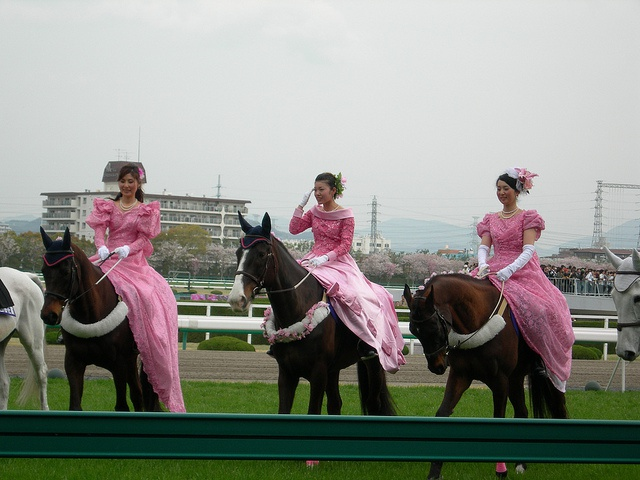Describe the objects in this image and their specific colors. I can see horse in lightgray, black, maroon, gray, and darkgreen tones, horse in lightgray, black, gray, darkgray, and darkgreen tones, people in lightgray, brown, and violet tones, people in lightgray, brown, lightpink, violet, and gray tones, and horse in lightgray, black, gray, darkgray, and maroon tones in this image. 